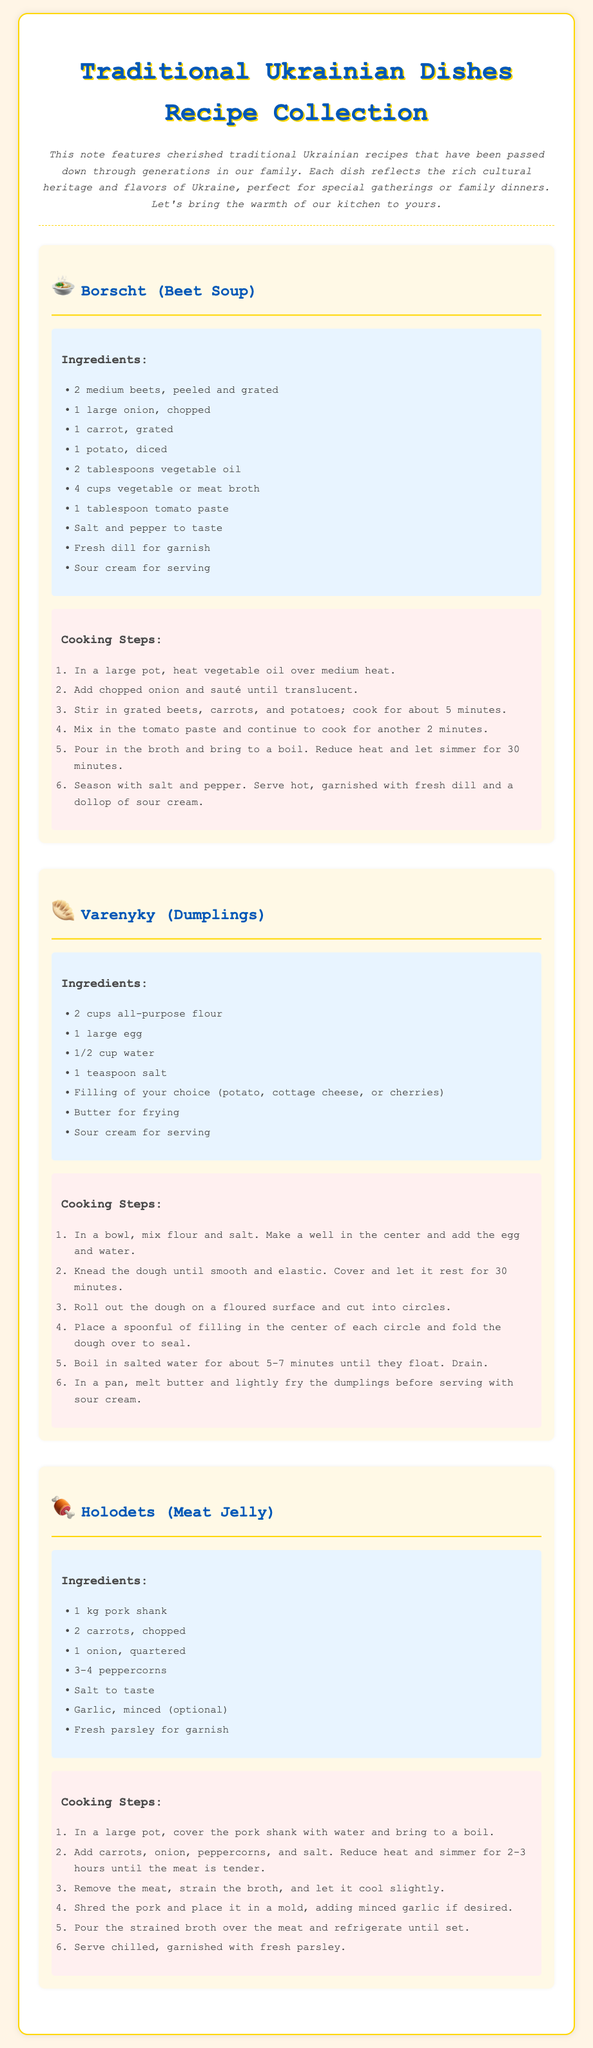What is the title of the collection? The title of the collection can be found at the top of the document, which is prominently displayed.
Answer: Traditional Ukrainian Dishes Recipe Collection How many recipes are included in the document? The document contains three distinct recipes presented in separate sections.
Answer: 3 What is the main ingredient in Borscht? The recipe for Borscht lists beets as the primary ingredient in the dish.
Answer: Beets Which dish uses all-purpose flour? The recipe that includes all-purpose flour is specifically noted among the provided recipes.
Answer: Varenyky How long should the dough for Varenyky rest? The document specifies a resting period for the dough in the instructions.
Answer: 30 minutes What is used for garnish in Holodets? The ingredients section for Holodets mentions a specific herb for garnish.
Answer: Fresh parsley What type of filling can be used in Varenyky? The filling options for Varenyky are mentioned in a list within the ingredients section.
Answer: Potato, cottage cheese, or cherries What is the cooking time for Borscht? The cooking steps outline a total simmering time needed for the Borscht preparation.
Answer: 30 minutes What is served with Borscht? The serving suggestion for Borscht includes a particular dairy product mentioned in the recipe.
Answer: Sour cream 